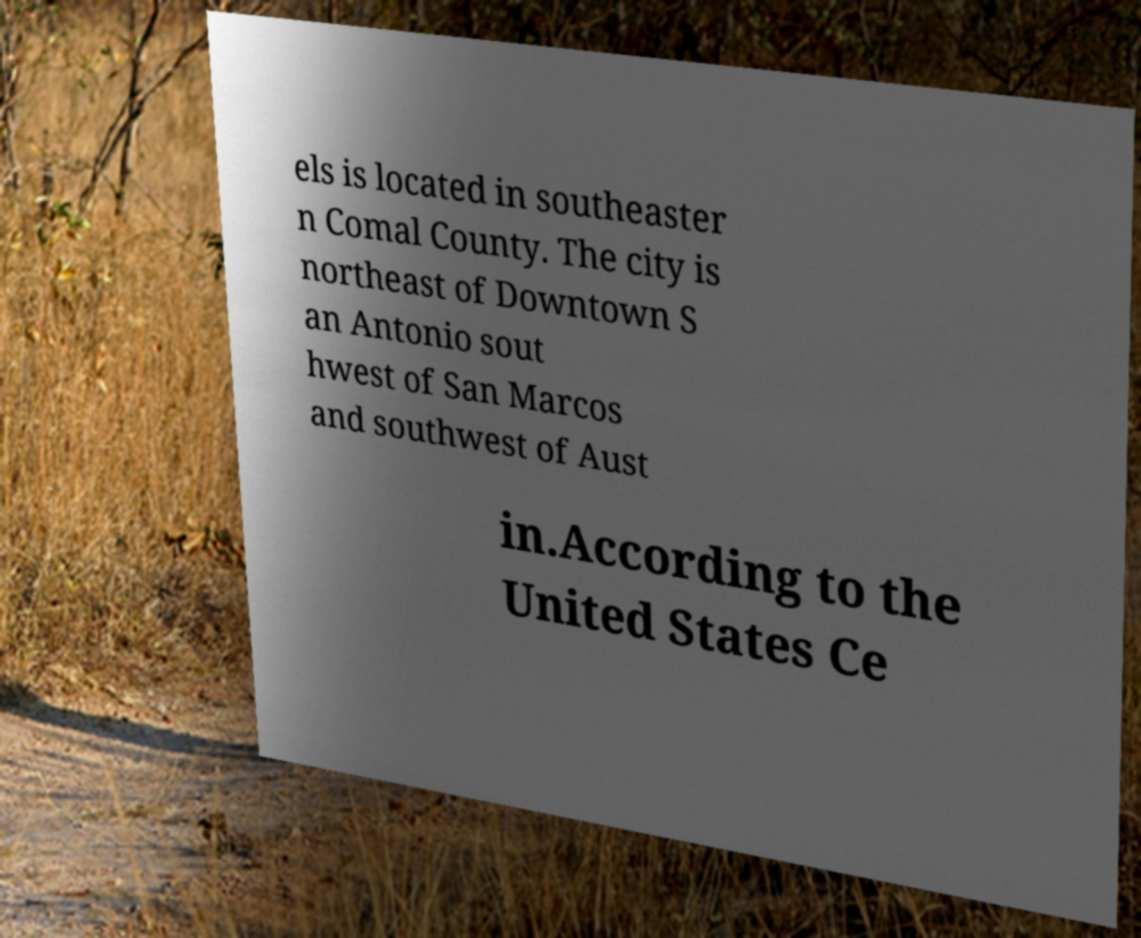Please identify and transcribe the text found in this image. els is located in southeaster n Comal County. The city is northeast of Downtown S an Antonio sout hwest of San Marcos and southwest of Aust in.According to the United States Ce 